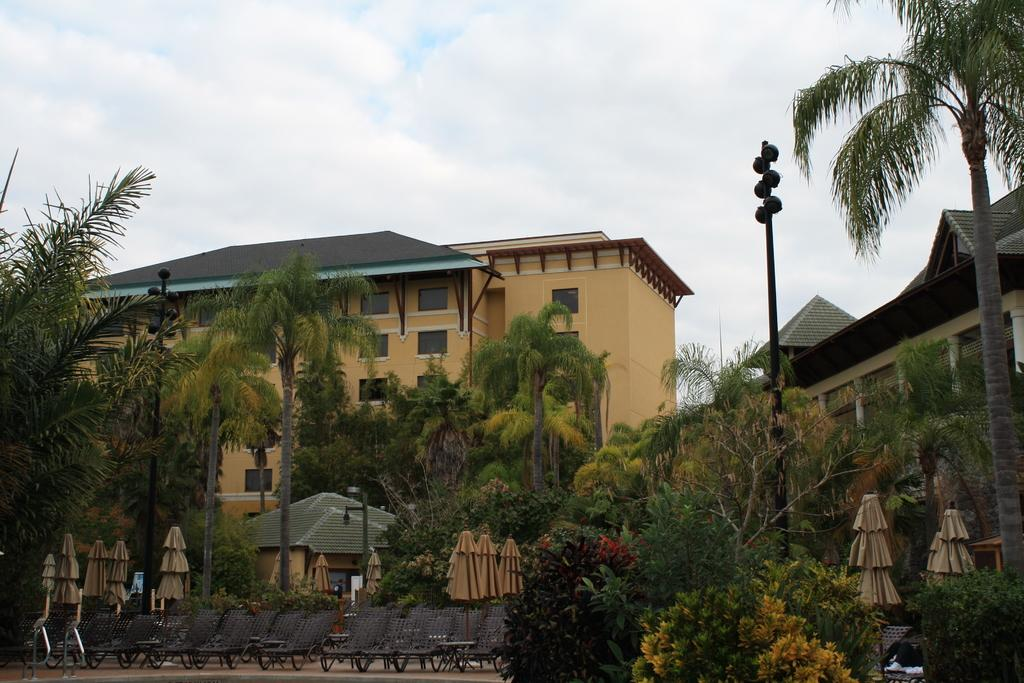What type of chairs are in the image? There are plank chairs in the image. What else is present in the image besides the chairs? There are closed umbrellas, a light-pole, trees, and buildings visible in the background of the image. Can you describe the sky in the image? The sky is blue and white in color. What other features can be seen on the buildings in the background? Windows are visible on the buildings in the background. What type of nose can be seen on the bean in the image? There is no bean or nose present in the image. What idea is being discussed by the chairs in the image? Chairs do not have the ability to discuss ideas, as they are inanimate objects. 